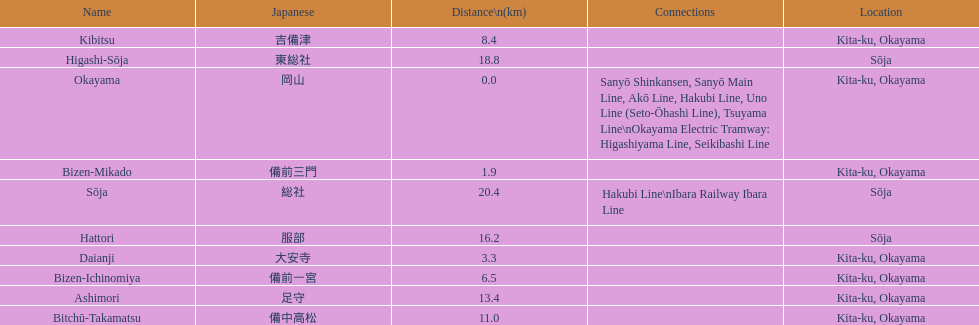How many stations have a distance below 15km? 7. 